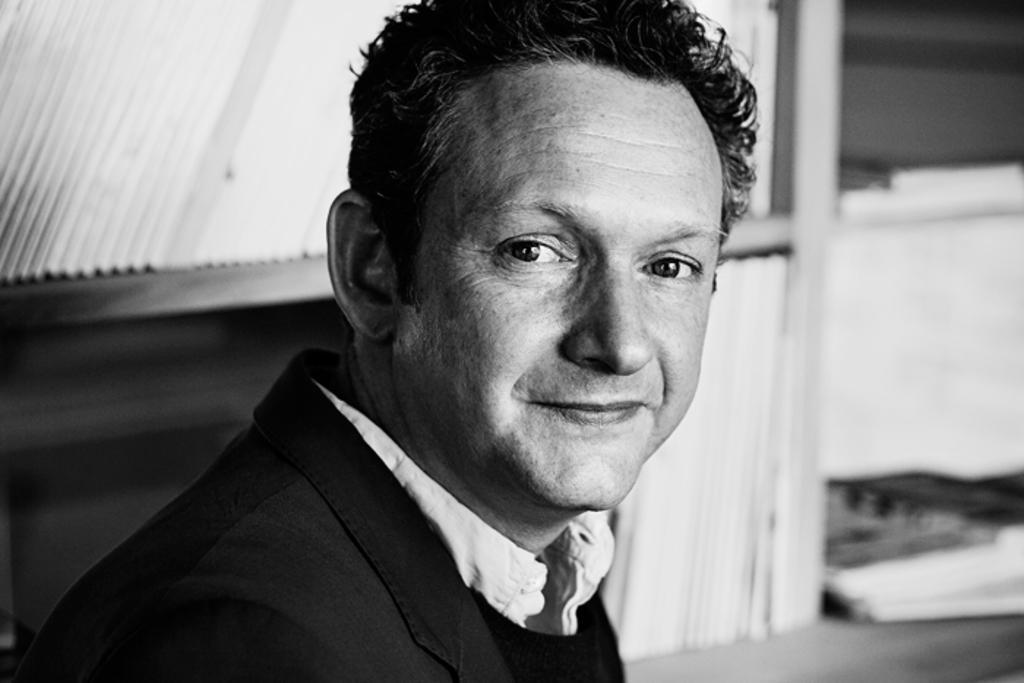In one or two sentences, can you explain what this image depicts? In this image I can see the black and white picture in which I can see a person wearing white shirt and black blazer is smiling and I can see the blurry background. 